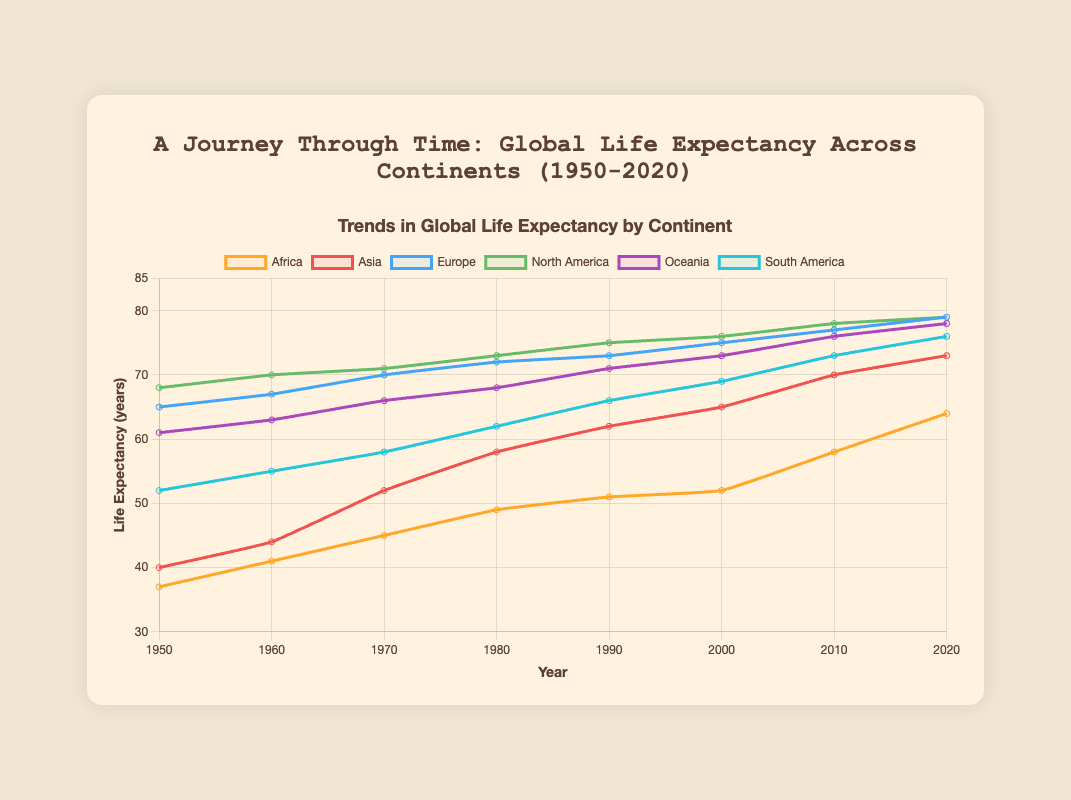Which continent had the highest life expectancy in 1950? By examining the plot, check the data point for each continent at the year 1950. North America has the highest data point.
Answer: North America How much did life expectancy in Africa change from 1950 to 2020? In 1950, the life expectancy in Africa was 37.0 years. In 2020, it was 64.0 years. The difference is calculated as 64.0 - 37.0 = 27.0 years.
Answer: 27 years Compare the life expectancy trend between Europe and Oceania in 1980. Which had a higher value? Locate the year 1980 on the x-axis and observe the lines corresponding to Europe and Oceania. Europe has a higher life expectancy than Oceania in 1980.
Answer: Europe By how many years did life expectancy in Asia increase from 1970 to 2010? In 1970, the life expectancy in Asia was 52.0 years. In 2010, it was 70.0 years. The increase is 70.0 - 52.0 = 18.0 years.
Answer: 18 years What is the average life expectancy of South America over the seven decades shown? Add the life expectancy values of South America from 1950 to 2020 (52.0 + 55.0 + 58.0 + 62.0 + 66.0 + 69.0 + 73.0 + 76.0) and divide by 8. The average is (411.0 / 8) ≈ 51.37 years.
Answer: 51.37 years Which continent exhibited the most significant improvement in life expectancy from 1950 to 2020? Calculate the difference in life expectancy for each continent from 1950 to 2020:
- Africa: 64.0 - 37.0 = 27.0
- Asia: 73.0 - 40.0 = 33.0
- Europe: 79.0 - 65.0 = 14.0
- North America: 79.0 - 68.0 = 11.0
- Oceania: 78.0 - 61.0 = 17.0
- South America: 76.0 - 52.0 = 24.0 
Asia has the highest increase.
Answer: Asia Compare the visual lines' steepness for Asia and Africa between 2000 to 2010. Which is steeper? Look at the slope of the lines between the years 2000 and 2010 for both Asia and Africa. The rise in life expectancy for Africa (58-52 = 6 years) over the ten years is more significant compared to Asia (70-65 = 5 years), indicating Africa's line is steeper.
Answer: Africa By how many years did North America's life expectancy increase from 1950 to 2020? Check the life expectancy values for North America in 1950 and 2020 and subtract the former from the latter (79 - 68 = 11 years).
Answer: 11 years Which continents have reached a life expectancy of over 75 years by 2020? Look at the data points for 2020 for each continent. Those over 75 years are Europe (79), North America (79), Oceania (78), and South America (76).
Answer: Europe, North America, Oceania, South America 